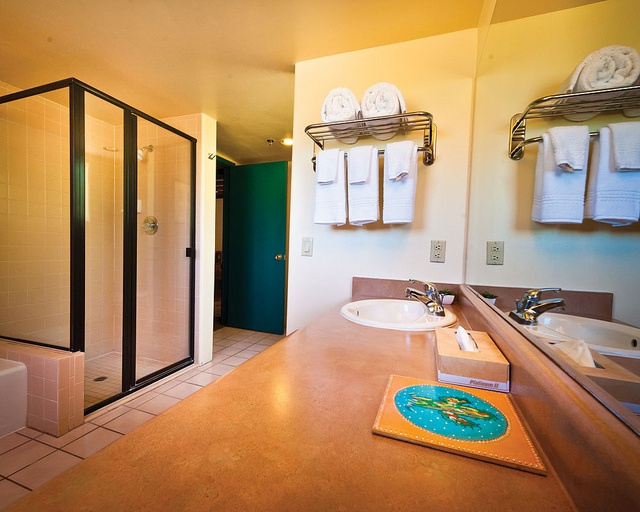Describe the objects in this image and their specific colors. I can see sink in tan, darkgray, and gray tones and sink in tan, lightgray, and brown tones in this image. 